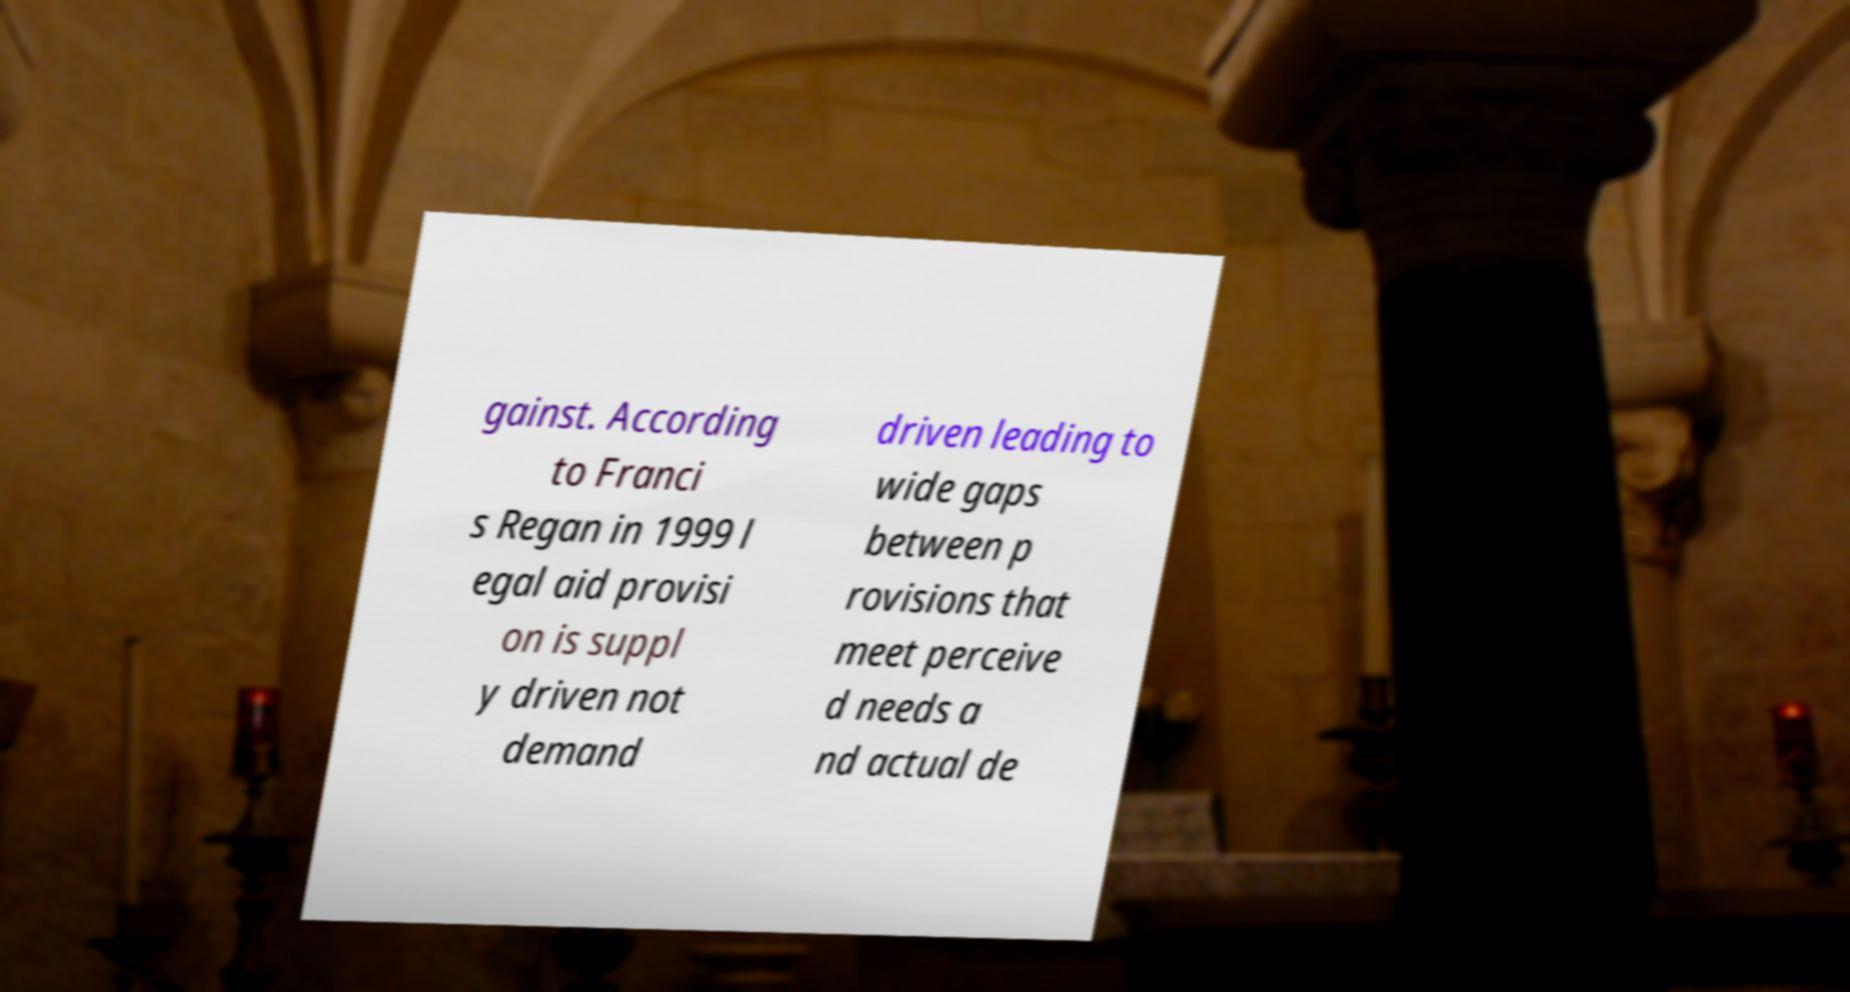Could you extract and type out the text from this image? gainst. According to Franci s Regan in 1999 l egal aid provisi on is suppl y driven not demand driven leading to wide gaps between p rovisions that meet perceive d needs a nd actual de 